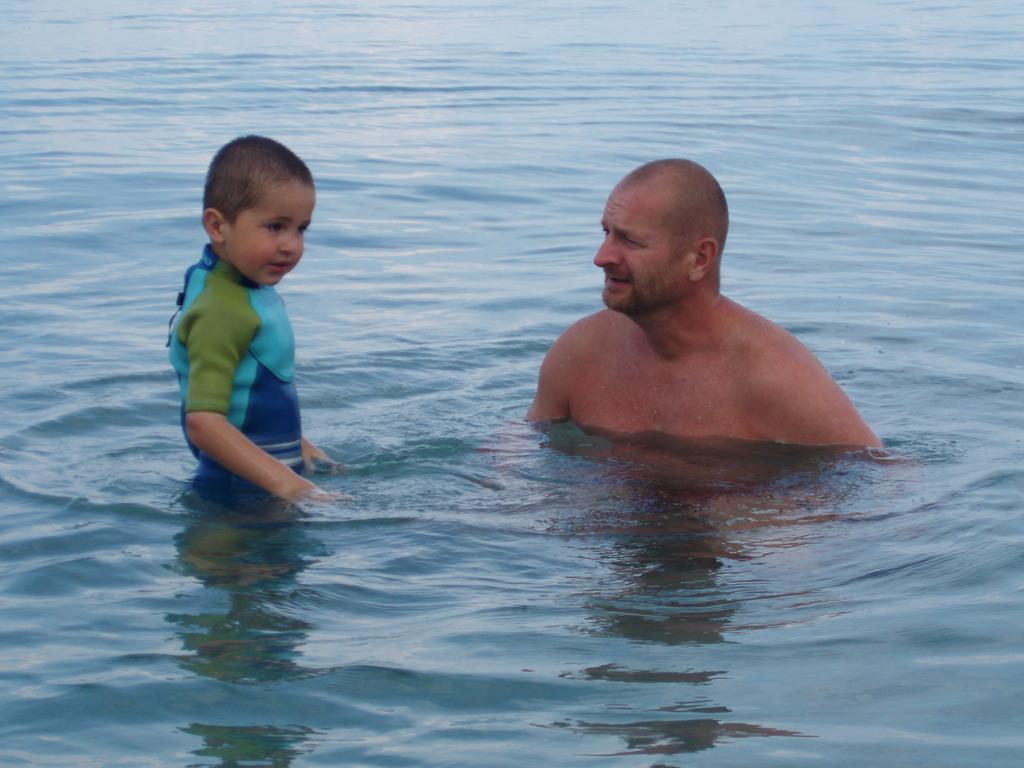Could you give a brief overview of what you see in this image? In this image we can see two persons in the water. 